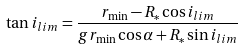Convert formula to latex. <formula><loc_0><loc_0><loc_500><loc_500>\tan i _ { l i m } = \frac { r _ { \min } - R _ { * } \cos i _ { l i m } } { g r _ { \min } \cos \alpha + R _ { * } \sin i _ { l i m } }</formula> 